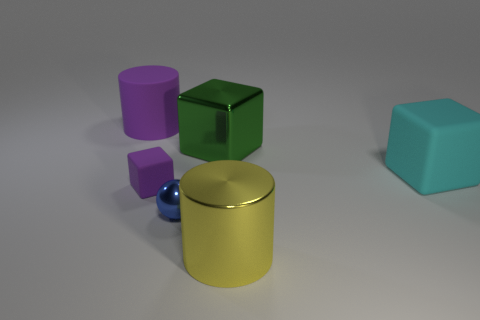Is the color of the small matte thing the same as the matte thing behind the large metal block?
Make the answer very short. Yes. Are there any big purple matte things of the same shape as the big yellow shiny thing?
Offer a very short reply. Yes. Is the shape of the purple thing that is right of the matte cylinder the same as the metallic object that is behind the cyan rubber thing?
Give a very brief answer. Yes. There is a small ball that is the same material as the green cube; what is its color?
Keep it short and to the point. Blue. Do the green cube and the object that is on the left side of the purple block have the same size?
Keep it short and to the point. Yes. What is the shape of the tiny purple matte thing?
Your response must be concise. Cube. What number of small rubber objects have the same color as the large rubber cylinder?
Ensure brevity in your answer.  1. There is a small thing that is the same shape as the big green shiny thing; what color is it?
Provide a short and direct response. Purple. There is a big object that is on the left side of the small purple rubber object; what number of purple cubes are in front of it?
Offer a very short reply. 1. What number of spheres are large purple rubber things or tiny blue things?
Your answer should be compact. 1. 